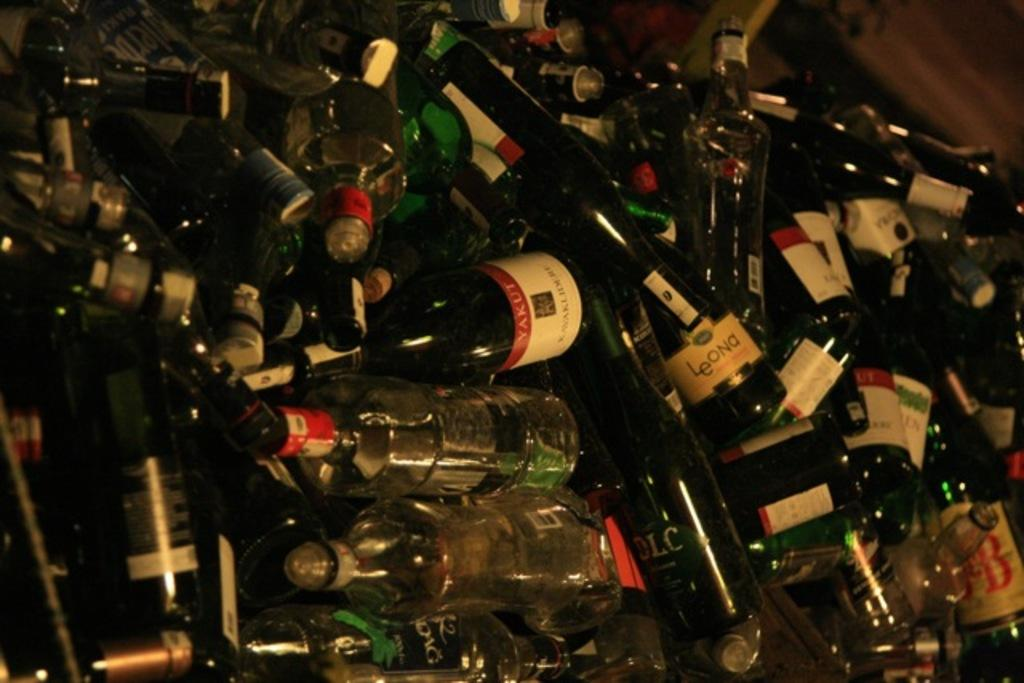<image>
Write a terse but informative summary of the picture. Hundreds of discarded glass bottles, including Yakut, in a bin. 